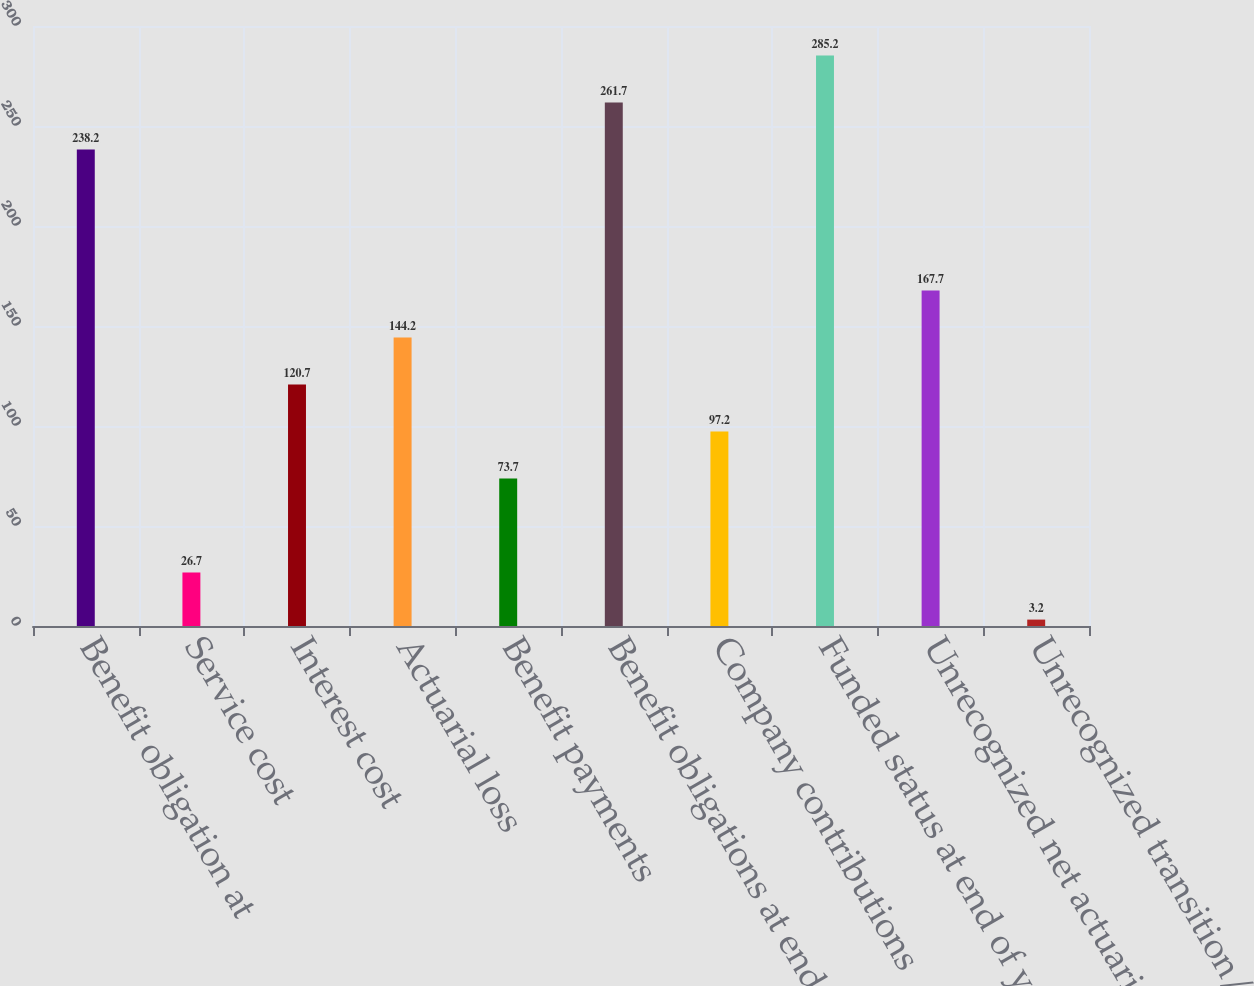<chart> <loc_0><loc_0><loc_500><loc_500><bar_chart><fcel>Benefit obligation at<fcel>Service cost<fcel>Interest cost<fcel>Actuarial loss<fcel>Benefit payments<fcel>Benefit obligations at end of<fcel>Company contributions<fcel>Funded status at end of year<fcel>Unrecognized net actuarial<fcel>Unrecognized transition/prior<nl><fcel>238.2<fcel>26.7<fcel>120.7<fcel>144.2<fcel>73.7<fcel>261.7<fcel>97.2<fcel>285.2<fcel>167.7<fcel>3.2<nl></chart> 